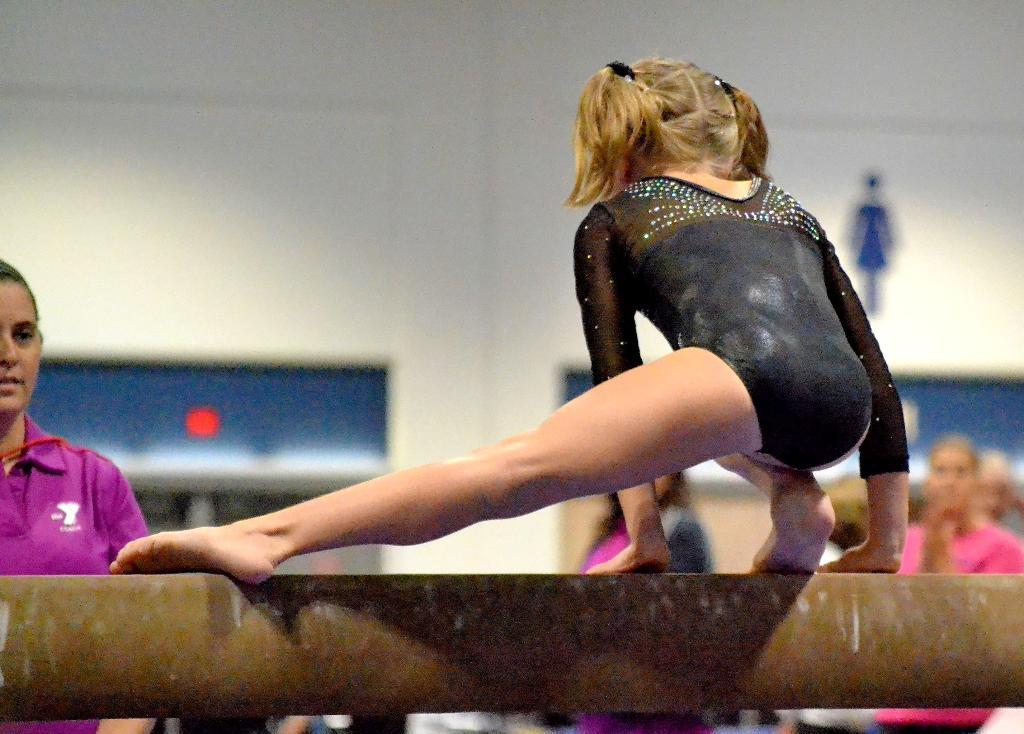Who is the main subject in the image? There is a girl in the image. What is the girl doing in the image? The girl is on a balancing beam. Can you describe the background of the image? There are people and a wall in the background of the image, and the background appears blurry. What type of space suit is the girl wearing in the image? There is no space suit present in the image; the girl is wearing clothing suitable for balancing on a beam. Can you see a sign in the background of the image? There is no sign visible in the image; the background features people and a wall. 